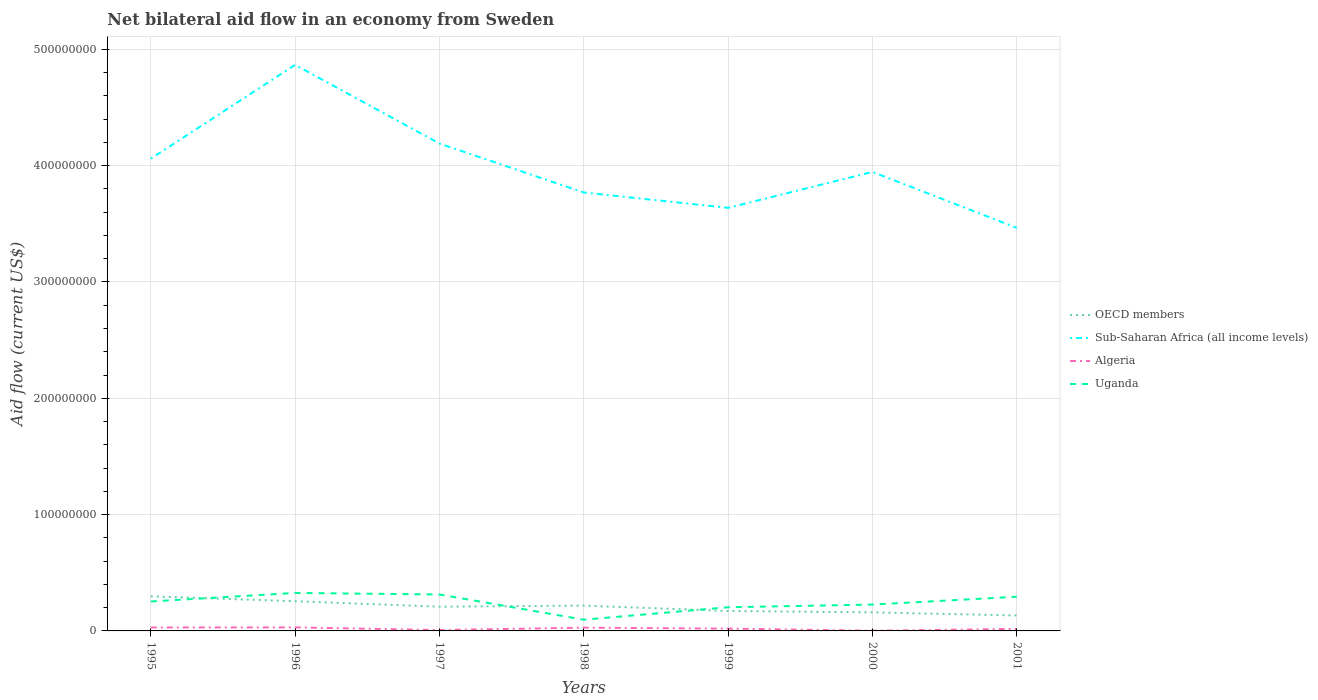Does the line corresponding to Sub-Saharan Africa (all income levels) intersect with the line corresponding to Uganda?
Provide a succinct answer. No. Is the number of lines equal to the number of legend labels?
Offer a terse response. Yes. Across all years, what is the maximum net bilateral aid flow in Sub-Saharan Africa (all income levels)?
Your response must be concise. 3.47e+08. In which year was the net bilateral aid flow in OECD members maximum?
Your answer should be compact. 2001. What is the total net bilateral aid flow in Algeria in the graph?
Your response must be concise. -9.60e+05. What is the difference between the highest and the second highest net bilateral aid flow in Uganda?
Offer a very short reply. 2.30e+07. Is the net bilateral aid flow in Sub-Saharan Africa (all income levels) strictly greater than the net bilateral aid flow in Algeria over the years?
Ensure brevity in your answer.  No. How many lines are there?
Give a very brief answer. 4. Does the graph contain any zero values?
Provide a short and direct response. No. Does the graph contain grids?
Give a very brief answer. Yes. Where does the legend appear in the graph?
Provide a succinct answer. Center right. How many legend labels are there?
Provide a succinct answer. 4. What is the title of the graph?
Provide a succinct answer. Net bilateral aid flow in an economy from Sweden. Does "Turkmenistan" appear as one of the legend labels in the graph?
Provide a succinct answer. No. What is the label or title of the X-axis?
Offer a terse response. Years. What is the Aid flow (current US$) of OECD members in 1995?
Keep it short and to the point. 2.97e+07. What is the Aid flow (current US$) in Sub-Saharan Africa (all income levels) in 1995?
Give a very brief answer. 4.06e+08. What is the Aid flow (current US$) in Algeria in 1995?
Keep it short and to the point. 2.96e+06. What is the Aid flow (current US$) in Uganda in 1995?
Keep it short and to the point. 2.53e+07. What is the Aid flow (current US$) in OECD members in 1996?
Your response must be concise. 2.55e+07. What is the Aid flow (current US$) of Sub-Saharan Africa (all income levels) in 1996?
Provide a succinct answer. 4.87e+08. What is the Aid flow (current US$) in Algeria in 1996?
Provide a succinct answer. 3.03e+06. What is the Aid flow (current US$) of Uganda in 1996?
Offer a terse response. 3.26e+07. What is the Aid flow (current US$) in OECD members in 1997?
Your answer should be very brief. 2.08e+07. What is the Aid flow (current US$) in Sub-Saharan Africa (all income levels) in 1997?
Your response must be concise. 4.19e+08. What is the Aid flow (current US$) of Algeria in 1997?
Offer a very short reply. 7.40e+05. What is the Aid flow (current US$) in Uganda in 1997?
Offer a very short reply. 3.13e+07. What is the Aid flow (current US$) in OECD members in 1998?
Provide a short and direct response. 2.18e+07. What is the Aid flow (current US$) in Sub-Saharan Africa (all income levels) in 1998?
Your answer should be very brief. 3.77e+08. What is the Aid flow (current US$) of Algeria in 1998?
Provide a short and direct response. 2.81e+06. What is the Aid flow (current US$) in Uganda in 1998?
Provide a short and direct response. 9.65e+06. What is the Aid flow (current US$) of OECD members in 1999?
Offer a very short reply. 1.72e+07. What is the Aid flow (current US$) of Sub-Saharan Africa (all income levels) in 1999?
Your answer should be very brief. 3.64e+08. What is the Aid flow (current US$) in Algeria in 1999?
Offer a very short reply. 1.95e+06. What is the Aid flow (current US$) in Uganda in 1999?
Make the answer very short. 2.03e+07. What is the Aid flow (current US$) in OECD members in 2000?
Provide a short and direct response. 1.60e+07. What is the Aid flow (current US$) in Sub-Saharan Africa (all income levels) in 2000?
Offer a terse response. 3.95e+08. What is the Aid flow (current US$) of Uganda in 2000?
Give a very brief answer. 2.26e+07. What is the Aid flow (current US$) in OECD members in 2001?
Your answer should be compact. 1.33e+07. What is the Aid flow (current US$) in Sub-Saharan Africa (all income levels) in 2001?
Your response must be concise. 3.47e+08. What is the Aid flow (current US$) in Algeria in 2001?
Make the answer very short. 1.70e+06. What is the Aid flow (current US$) of Uganda in 2001?
Offer a very short reply. 2.94e+07. Across all years, what is the maximum Aid flow (current US$) of OECD members?
Your response must be concise. 2.97e+07. Across all years, what is the maximum Aid flow (current US$) in Sub-Saharan Africa (all income levels)?
Your answer should be very brief. 4.87e+08. Across all years, what is the maximum Aid flow (current US$) of Algeria?
Give a very brief answer. 3.03e+06. Across all years, what is the maximum Aid flow (current US$) in Uganda?
Provide a short and direct response. 3.26e+07. Across all years, what is the minimum Aid flow (current US$) of OECD members?
Make the answer very short. 1.33e+07. Across all years, what is the minimum Aid flow (current US$) of Sub-Saharan Africa (all income levels)?
Make the answer very short. 3.47e+08. Across all years, what is the minimum Aid flow (current US$) of Uganda?
Your response must be concise. 9.65e+06. What is the total Aid flow (current US$) of OECD members in the graph?
Offer a terse response. 1.44e+08. What is the total Aid flow (current US$) of Sub-Saharan Africa (all income levels) in the graph?
Provide a short and direct response. 2.79e+09. What is the total Aid flow (current US$) in Algeria in the graph?
Offer a very short reply. 1.34e+07. What is the total Aid flow (current US$) in Uganda in the graph?
Make the answer very short. 1.71e+08. What is the difference between the Aid flow (current US$) of OECD members in 1995 and that in 1996?
Your answer should be very brief. 4.21e+06. What is the difference between the Aid flow (current US$) in Sub-Saharan Africa (all income levels) in 1995 and that in 1996?
Your answer should be very brief. -8.06e+07. What is the difference between the Aid flow (current US$) of Uganda in 1995 and that in 1996?
Offer a terse response. -7.34e+06. What is the difference between the Aid flow (current US$) in OECD members in 1995 and that in 1997?
Keep it short and to the point. 8.90e+06. What is the difference between the Aid flow (current US$) of Sub-Saharan Africa (all income levels) in 1995 and that in 1997?
Your answer should be very brief. -1.30e+07. What is the difference between the Aid flow (current US$) in Algeria in 1995 and that in 1997?
Ensure brevity in your answer.  2.22e+06. What is the difference between the Aid flow (current US$) of Uganda in 1995 and that in 1997?
Keep it short and to the point. -6.02e+06. What is the difference between the Aid flow (current US$) of OECD members in 1995 and that in 1998?
Keep it short and to the point. 7.98e+06. What is the difference between the Aid flow (current US$) of Sub-Saharan Africa (all income levels) in 1995 and that in 1998?
Your answer should be compact. 2.91e+07. What is the difference between the Aid flow (current US$) in Algeria in 1995 and that in 1998?
Keep it short and to the point. 1.50e+05. What is the difference between the Aid flow (current US$) of Uganda in 1995 and that in 1998?
Provide a short and direct response. 1.57e+07. What is the difference between the Aid flow (current US$) of OECD members in 1995 and that in 1999?
Offer a terse response. 1.26e+07. What is the difference between the Aid flow (current US$) in Sub-Saharan Africa (all income levels) in 1995 and that in 1999?
Make the answer very short. 4.23e+07. What is the difference between the Aid flow (current US$) of Algeria in 1995 and that in 1999?
Offer a very short reply. 1.01e+06. What is the difference between the Aid flow (current US$) of Uganda in 1995 and that in 1999?
Make the answer very short. 4.97e+06. What is the difference between the Aid flow (current US$) in OECD members in 1995 and that in 2000?
Your response must be concise. 1.38e+07. What is the difference between the Aid flow (current US$) in Sub-Saharan Africa (all income levels) in 1995 and that in 2000?
Give a very brief answer. 1.14e+07. What is the difference between the Aid flow (current US$) of Algeria in 1995 and that in 2000?
Keep it short and to the point. 2.76e+06. What is the difference between the Aid flow (current US$) in Uganda in 1995 and that in 2000?
Provide a succinct answer. 2.66e+06. What is the difference between the Aid flow (current US$) of OECD members in 1995 and that in 2001?
Keep it short and to the point. 1.64e+07. What is the difference between the Aid flow (current US$) in Sub-Saharan Africa (all income levels) in 1995 and that in 2001?
Provide a short and direct response. 5.94e+07. What is the difference between the Aid flow (current US$) in Algeria in 1995 and that in 2001?
Ensure brevity in your answer.  1.26e+06. What is the difference between the Aid flow (current US$) in Uganda in 1995 and that in 2001?
Your answer should be compact. -4.09e+06. What is the difference between the Aid flow (current US$) in OECD members in 1996 and that in 1997?
Ensure brevity in your answer.  4.69e+06. What is the difference between the Aid flow (current US$) of Sub-Saharan Africa (all income levels) in 1996 and that in 1997?
Ensure brevity in your answer.  6.76e+07. What is the difference between the Aid flow (current US$) of Algeria in 1996 and that in 1997?
Ensure brevity in your answer.  2.29e+06. What is the difference between the Aid flow (current US$) in Uganda in 1996 and that in 1997?
Ensure brevity in your answer.  1.32e+06. What is the difference between the Aid flow (current US$) in OECD members in 1996 and that in 1998?
Keep it short and to the point. 3.77e+06. What is the difference between the Aid flow (current US$) of Sub-Saharan Africa (all income levels) in 1996 and that in 1998?
Your response must be concise. 1.10e+08. What is the difference between the Aid flow (current US$) in Algeria in 1996 and that in 1998?
Your response must be concise. 2.20e+05. What is the difference between the Aid flow (current US$) in Uganda in 1996 and that in 1998?
Offer a very short reply. 2.30e+07. What is the difference between the Aid flow (current US$) in OECD members in 1996 and that in 1999?
Offer a terse response. 8.38e+06. What is the difference between the Aid flow (current US$) in Sub-Saharan Africa (all income levels) in 1996 and that in 1999?
Offer a terse response. 1.23e+08. What is the difference between the Aid flow (current US$) of Algeria in 1996 and that in 1999?
Keep it short and to the point. 1.08e+06. What is the difference between the Aid flow (current US$) of Uganda in 1996 and that in 1999?
Offer a terse response. 1.23e+07. What is the difference between the Aid flow (current US$) in OECD members in 1996 and that in 2000?
Your answer should be very brief. 9.57e+06. What is the difference between the Aid flow (current US$) in Sub-Saharan Africa (all income levels) in 1996 and that in 2000?
Offer a terse response. 9.20e+07. What is the difference between the Aid flow (current US$) in Algeria in 1996 and that in 2000?
Keep it short and to the point. 2.83e+06. What is the difference between the Aid flow (current US$) in OECD members in 1996 and that in 2001?
Your response must be concise. 1.22e+07. What is the difference between the Aid flow (current US$) of Sub-Saharan Africa (all income levels) in 1996 and that in 2001?
Your response must be concise. 1.40e+08. What is the difference between the Aid flow (current US$) of Algeria in 1996 and that in 2001?
Your answer should be compact. 1.33e+06. What is the difference between the Aid flow (current US$) in Uganda in 1996 and that in 2001?
Provide a short and direct response. 3.25e+06. What is the difference between the Aid flow (current US$) in OECD members in 1997 and that in 1998?
Ensure brevity in your answer.  -9.20e+05. What is the difference between the Aid flow (current US$) of Sub-Saharan Africa (all income levels) in 1997 and that in 1998?
Your answer should be compact. 4.21e+07. What is the difference between the Aid flow (current US$) of Algeria in 1997 and that in 1998?
Your response must be concise. -2.07e+06. What is the difference between the Aid flow (current US$) of Uganda in 1997 and that in 1998?
Your answer should be very brief. 2.17e+07. What is the difference between the Aid flow (current US$) of OECD members in 1997 and that in 1999?
Make the answer very short. 3.69e+06. What is the difference between the Aid flow (current US$) in Sub-Saharan Africa (all income levels) in 1997 and that in 1999?
Provide a succinct answer. 5.53e+07. What is the difference between the Aid flow (current US$) of Algeria in 1997 and that in 1999?
Give a very brief answer. -1.21e+06. What is the difference between the Aid flow (current US$) of Uganda in 1997 and that in 1999?
Make the answer very short. 1.10e+07. What is the difference between the Aid flow (current US$) in OECD members in 1997 and that in 2000?
Your answer should be compact. 4.88e+06. What is the difference between the Aid flow (current US$) in Sub-Saharan Africa (all income levels) in 1997 and that in 2000?
Your answer should be very brief. 2.44e+07. What is the difference between the Aid flow (current US$) in Algeria in 1997 and that in 2000?
Ensure brevity in your answer.  5.40e+05. What is the difference between the Aid flow (current US$) in Uganda in 1997 and that in 2000?
Give a very brief answer. 8.68e+06. What is the difference between the Aid flow (current US$) of OECD members in 1997 and that in 2001?
Your answer should be compact. 7.55e+06. What is the difference between the Aid flow (current US$) in Sub-Saharan Africa (all income levels) in 1997 and that in 2001?
Ensure brevity in your answer.  7.25e+07. What is the difference between the Aid flow (current US$) of Algeria in 1997 and that in 2001?
Provide a short and direct response. -9.60e+05. What is the difference between the Aid flow (current US$) of Uganda in 1997 and that in 2001?
Give a very brief answer. 1.93e+06. What is the difference between the Aid flow (current US$) of OECD members in 1998 and that in 1999?
Ensure brevity in your answer.  4.61e+06. What is the difference between the Aid flow (current US$) of Sub-Saharan Africa (all income levels) in 1998 and that in 1999?
Provide a succinct answer. 1.32e+07. What is the difference between the Aid flow (current US$) of Algeria in 1998 and that in 1999?
Offer a very short reply. 8.60e+05. What is the difference between the Aid flow (current US$) in Uganda in 1998 and that in 1999?
Keep it short and to the point. -1.07e+07. What is the difference between the Aid flow (current US$) of OECD members in 1998 and that in 2000?
Keep it short and to the point. 5.80e+06. What is the difference between the Aid flow (current US$) in Sub-Saharan Africa (all income levels) in 1998 and that in 2000?
Ensure brevity in your answer.  -1.77e+07. What is the difference between the Aid flow (current US$) in Algeria in 1998 and that in 2000?
Give a very brief answer. 2.61e+06. What is the difference between the Aid flow (current US$) of Uganda in 1998 and that in 2000?
Provide a succinct answer. -1.30e+07. What is the difference between the Aid flow (current US$) in OECD members in 1998 and that in 2001?
Your answer should be compact. 8.47e+06. What is the difference between the Aid flow (current US$) of Sub-Saharan Africa (all income levels) in 1998 and that in 2001?
Your answer should be compact. 3.04e+07. What is the difference between the Aid flow (current US$) in Algeria in 1998 and that in 2001?
Your answer should be compact. 1.11e+06. What is the difference between the Aid flow (current US$) of Uganda in 1998 and that in 2001?
Offer a very short reply. -1.98e+07. What is the difference between the Aid flow (current US$) in OECD members in 1999 and that in 2000?
Provide a succinct answer. 1.19e+06. What is the difference between the Aid flow (current US$) of Sub-Saharan Africa (all income levels) in 1999 and that in 2000?
Give a very brief answer. -3.09e+07. What is the difference between the Aid flow (current US$) of Algeria in 1999 and that in 2000?
Offer a very short reply. 1.75e+06. What is the difference between the Aid flow (current US$) in Uganda in 1999 and that in 2000?
Give a very brief answer. -2.31e+06. What is the difference between the Aid flow (current US$) of OECD members in 1999 and that in 2001?
Offer a terse response. 3.86e+06. What is the difference between the Aid flow (current US$) in Sub-Saharan Africa (all income levels) in 1999 and that in 2001?
Your answer should be compact. 1.72e+07. What is the difference between the Aid flow (current US$) in Algeria in 1999 and that in 2001?
Make the answer very short. 2.50e+05. What is the difference between the Aid flow (current US$) of Uganda in 1999 and that in 2001?
Keep it short and to the point. -9.06e+06. What is the difference between the Aid flow (current US$) of OECD members in 2000 and that in 2001?
Keep it short and to the point. 2.67e+06. What is the difference between the Aid flow (current US$) in Sub-Saharan Africa (all income levels) in 2000 and that in 2001?
Your answer should be compact. 4.81e+07. What is the difference between the Aid flow (current US$) in Algeria in 2000 and that in 2001?
Give a very brief answer. -1.50e+06. What is the difference between the Aid flow (current US$) of Uganda in 2000 and that in 2001?
Offer a very short reply. -6.75e+06. What is the difference between the Aid flow (current US$) in OECD members in 1995 and the Aid flow (current US$) in Sub-Saharan Africa (all income levels) in 1996?
Provide a succinct answer. -4.57e+08. What is the difference between the Aid flow (current US$) of OECD members in 1995 and the Aid flow (current US$) of Algeria in 1996?
Offer a terse response. 2.67e+07. What is the difference between the Aid flow (current US$) in OECD members in 1995 and the Aid flow (current US$) in Uganda in 1996?
Provide a succinct answer. -2.91e+06. What is the difference between the Aid flow (current US$) in Sub-Saharan Africa (all income levels) in 1995 and the Aid flow (current US$) in Algeria in 1996?
Offer a very short reply. 4.03e+08. What is the difference between the Aid flow (current US$) in Sub-Saharan Africa (all income levels) in 1995 and the Aid flow (current US$) in Uganda in 1996?
Your response must be concise. 3.73e+08. What is the difference between the Aid flow (current US$) in Algeria in 1995 and the Aid flow (current US$) in Uganda in 1996?
Keep it short and to the point. -2.97e+07. What is the difference between the Aid flow (current US$) of OECD members in 1995 and the Aid flow (current US$) of Sub-Saharan Africa (all income levels) in 1997?
Provide a succinct answer. -3.89e+08. What is the difference between the Aid flow (current US$) of OECD members in 1995 and the Aid flow (current US$) of Algeria in 1997?
Give a very brief answer. 2.90e+07. What is the difference between the Aid flow (current US$) in OECD members in 1995 and the Aid flow (current US$) in Uganda in 1997?
Offer a very short reply. -1.59e+06. What is the difference between the Aid flow (current US$) in Sub-Saharan Africa (all income levels) in 1995 and the Aid flow (current US$) in Algeria in 1997?
Ensure brevity in your answer.  4.05e+08. What is the difference between the Aid flow (current US$) in Sub-Saharan Africa (all income levels) in 1995 and the Aid flow (current US$) in Uganda in 1997?
Keep it short and to the point. 3.75e+08. What is the difference between the Aid flow (current US$) of Algeria in 1995 and the Aid flow (current US$) of Uganda in 1997?
Make the answer very short. -2.84e+07. What is the difference between the Aid flow (current US$) in OECD members in 1995 and the Aid flow (current US$) in Sub-Saharan Africa (all income levels) in 1998?
Offer a very short reply. -3.47e+08. What is the difference between the Aid flow (current US$) of OECD members in 1995 and the Aid flow (current US$) of Algeria in 1998?
Your answer should be very brief. 2.69e+07. What is the difference between the Aid flow (current US$) in OECD members in 1995 and the Aid flow (current US$) in Uganda in 1998?
Provide a short and direct response. 2.01e+07. What is the difference between the Aid flow (current US$) in Sub-Saharan Africa (all income levels) in 1995 and the Aid flow (current US$) in Algeria in 1998?
Provide a succinct answer. 4.03e+08. What is the difference between the Aid flow (current US$) in Sub-Saharan Africa (all income levels) in 1995 and the Aid flow (current US$) in Uganda in 1998?
Keep it short and to the point. 3.96e+08. What is the difference between the Aid flow (current US$) of Algeria in 1995 and the Aid flow (current US$) of Uganda in 1998?
Your response must be concise. -6.69e+06. What is the difference between the Aid flow (current US$) in OECD members in 1995 and the Aid flow (current US$) in Sub-Saharan Africa (all income levels) in 1999?
Your answer should be compact. -3.34e+08. What is the difference between the Aid flow (current US$) of OECD members in 1995 and the Aid flow (current US$) of Algeria in 1999?
Give a very brief answer. 2.78e+07. What is the difference between the Aid flow (current US$) of OECD members in 1995 and the Aid flow (current US$) of Uganda in 1999?
Your answer should be very brief. 9.40e+06. What is the difference between the Aid flow (current US$) of Sub-Saharan Africa (all income levels) in 1995 and the Aid flow (current US$) of Algeria in 1999?
Give a very brief answer. 4.04e+08. What is the difference between the Aid flow (current US$) in Sub-Saharan Africa (all income levels) in 1995 and the Aid flow (current US$) in Uganda in 1999?
Offer a very short reply. 3.86e+08. What is the difference between the Aid flow (current US$) in Algeria in 1995 and the Aid flow (current US$) in Uganda in 1999?
Your response must be concise. -1.74e+07. What is the difference between the Aid flow (current US$) of OECD members in 1995 and the Aid flow (current US$) of Sub-Saharan Africa (all income levels) in 2000?
Your answer should be compact. -3.65e+08. What is the difference between the Aid flow (current US$) in OECD members in 1995 and the Aid flow (current US$) in Algeria in 2000?
Your answer should be very brief. 2.95e+07. What is the difference between the Aid flow (current US$) in OECD members in 1995 and the Aid flow (current US$) in Uganda in 2000?
Ensure brevity in your answer.  7.09e+06. What is the difference between the Aid flow (current US$) of Sub-Saharan Africa (all income levels) in 1995 and the Aid flow (current US$) of Algeria in 2000?
Your response must be concise. 4.06e+08. What is the difference between the Aid flow (current US$) of Sub-Saharan Africa (all income levels) in 1995 and the Aid flow (current US$) of Uganda in 2000?
Keep it short and to the point. 3.83e+08. What is the difference between the Aid flow (current US$) in Algeria in 1995 and the Aid flow (current US$) in Uganda in 2000?
Keep it short and to the point. -1.97e+07. What is the difference between the Aid flow (current US$) in OECD members in 1995 and the Aid flow (current US$) in Sub-Saharan Africa (all income levels) in 2001?
Offer a very short reply. -3.17e+08. What is the difference between the Aid flow (current US$) of OECD members in 1995 and the Aid flow (current US$) of Algeria in 2001?
Provide a short and direct response. 2.80e+07. What is the difference between the Aid flow (current US$) of Sub-Saharan Africa (all income levels) in 1995 and the Aid flow (current US$) of Algeria in 2001?
Provide a succinct answer. 4.04e+08. What is the difference between the Aid flow (current US$) of Sub-Saharan Africa (all income levels) in 1995 and the Aid flow (current US$) of Uganda in 2001?
Offer a terse response. 3.77e+08. What is the difference between the Aid flow (current US$) in Algeria in 1995 and the Aid flow (current US$) in Uganda in 2001?
Offer a terse response. -2.64e+07. What is the difference between the Aid flow (current US$) in OECD members in 1996 and the Aid flow (current US$) in Sub-Saharan Africa (all income levels) in 1997?
Your answer should be very brief. -3.93e+08. What is the difference between the Aid flow (current US$) of OECD members in 1996 and the Aid flow (current US$) of Algeria in 1997?
Provide a short and direct response. 2.48e+07. What is the difference between the Aid flow (current US$) of OECD members in 1996 and the Aid flow (current US$) of Uganda in 1997?
Give a very brief answer. -5.80e+06. What is the difference between the Aid flow (current US$) of Sub-Saharan Africa (all income levels) in 1996 and the Aid flow (current US$) of Algeria in 1997?
Keep it short and to the point. 4.86e+08. What is the difference between the Aid flow (current US$) of Sub-Saharan Africa (all income levels) in 1996 and the Aid flow (current US$) of Uganda in 1997?
Ensure brevity in your answer.  4.55e+08. What is the difference between the Aid flow (current US$) in Algeria in 1996 and the Aid flow (current US$) in Uganda in 1997?
Your answer should be compact. -2.83e+07. What is the difference between the Aid flow (current US$) of OECD members in 1996 and the Aid flow (current US$) of Sub-Saharan Africa (all income levels) in 1998?
Your response must be concise. -3.51e+08. What is the difference between the Aid flow (current US$) of OECD members in 1996 and the Aid flow (current US$) of Algeria in 1998?
Your response must be concise. 2.27e+07. What is the difference between the Aid flow (current US$) of OECD members in 1996 and the Aid flow (current US$) of Uganda in 1998?
Your answer should be very brief. 1.59e+07. What is the difference between the Aid flow (current US$) of Sub-Saharan Africa (all income levels) in 1996 and the Aid flow (current US$) of Algeria in 1998?
Ensure brevity in your answer.  4.84e+08. What is the difference between the Aid flow (current US$) of Sub-Saharan Africa (all income levels) in 1996 and the Aid flow (current US$) of Uganda in 1998?
Offer a very short reply. 4.77e+08. What is the difference between the Aid flow (current US$) of Algeria in 1996 and the Aid flow (current US$) of Uganda in 1998?
Ensure brevity in your answer.  -6.62e+06. What is the difference between the Aid flow (current US$) of OECD members in 1996 and the Aid flow (current US$) of Sub-Saharan Africa (all income levels) in 1999?
Offer a very short reply. -3.38e+08. What is the difference between the Aid flow (current US$) of OECD members in 1996 and the Aid flow (current US$) of Algeria in 1999?
Ensure brevity in your answer.  2.36e+07. What is the difference between the Aid flow (current US$) in OECD members in 1996 and the Aid flow (current US$) in Uganda in 1999?
Offer a terse response. 5.19e+06. What is the difference between the Aid flow (current US$) of Sub-Saharan Africa (all income levels) in 1996 and the Aid flow (current US$) of Algeria in 1999?
Ensure brevity in your answer.  4.85e+08. What is the difference between the Aid flow (current US$) in Sub-Saharan Africa (all income levels) in 1996 and the Aid flow (current US$) in Uganda in 1999?
Provide a short and direct response. 4.66e+08. What is the difference between the Aid flow (current US$) of Algeria in 1996 and the Aid flow (current US$) of Uganda in 1999?
Offer a terse response. -1.73e+07. What is the difference between the Aid flow (current US$) of OECD members in 1996 and the Aid flow (current US$) of Sub-Saharan Africa (all income levels) in 2000?
Offer a very short reply. -3.69e+08. What is the difference between the Aid flow (current US$) of OECD members in 1996 and the Aid flow (current US$) of Algeria in 2000?
Provide a short and direct response. 2.53e+07. What is the difference between the Aid flow (current US$) of OECD members in 1996 and the Aid flow (current US$) of Uganda in 2000?
Your response must be concise. 2.88e+06. What is the difference between the Aid flow (current US$) in Sub-Saharan Africa (all income levels) in 1996 and the Aid flow (current US$) in Algeria in 2000?
Offer a very short reply. 4.86e+08. What is the difference between the Aid flow (current US$) in Sub-Saharan Africa (all income levels) in 1996 and the Aid flow (current US$) in Uganda in 2000?
Your response must be concise. 4.64e+08. What is the difference between the Aid flow (current US$) of Algeria in 1996 and the Aid flow (current US$) of Uganda in 2000?
Make the answer very short. -1.96e+07. What is the difference between the Aid flow (current US$) of OECD members in 1996 and the Aid flow (current US$) of Sub-Saharan Africa (all income levels) in 2001?
Provide a short and direct response. -3.21e+08. What is the difference between the Aid flow (current US$) in OECD members in 1996 and the Aid flow (current US$) in Algeria in 2001?
Your response must be concise. 2.38e+07. What is the difference between the Aid flow (current US$) in OECD members in 1996 and the Aid flow (current US$) in Uganda in 2001?
Your answer should be compact. -3.87e+06. What is the difference between the Aid flow (current US$) in Sub-Saharan Africa (all income levels) in 1996 and the Aid flow (current US$) in Algeria in 2001?
Give a very brief answer. 4.85e+08. What is the difference between the Aid flow (current US$) in Sub-Saharan Africa (all income levels) in 1996 and the Aid flow (current US$) in Uganda in 2001?
Provide a succinct answer. 4.57e+08. What is the difference between the Aid flow (current US$) in Algeria in 1996 and the Aid flow (current US$) in Uganda in 2001?
Give a very brief answer. -2.64e+07. What is the difference between the Aid flow (current US$) of OECD members in 1997 and the Aid flow (current US$) of Sub-Saharan Africa (all income levels) in 1998?
Offer a terse response. -3.56e+08. What is the difference between the Aid flow (current US$) of OECD members in 1997 and the Aid flow (current US$) of Algeria in 1998?
Your answer should be compact. 1.80e+07. What is the difference between the Aid flow (current US$) in OECD members in 1997 and the Aid flow (current US$) in Uganda in 1998?
Your response must be concise. 1.12e+07. What is the difference between the Aid flow (current US$) of Sub-Saharan Africa (all income levels) in 1997 and the Aid flow (current US$) of Algeria in 1998?
Keep it short and to the point. 4.16e+08. What is the difference between the Aid flow (current US$) of Sub-Saharan Africa (all income levels) in 1997 and the Aid flow (current US$) of Uganda in 1998?
Give a very brief answer. 4.09e+08. What is the difference between the Aid flow (current US$) in Algeria in 1997 and the Aid flow (current US$) in Uganda in 1998?
Your answer should be very brief. -8.91e+06. What is the difference between the Aid flow (current US$) in OECD members in 1997 and the Aid flow (current US$) in Sub-Saharan Africa (all income levels) in 1999?
Your answer should be compact. -3.43e+08. What is the difference between the Aid flow (current US$) in OECD members in 1997 and the Aid flow (current US$) in Algeria in 1999?
Your answer should be very brief. 1.89e+07. What is the difference between the Aid flow (current US$) of OECD members in 1997 and the Aid flow (current US$) of Uganda in 1999?
Offer a very short reply. 5.00e+05. What is the difference between the Aid flow (current US$) in Sub-Saharan Africa (all income levels) in 1997 and the Aid flow (current US$) in Algeria in 1999?
Your response must be concise. 4.17e+08. What is the difference between the Aid flow (current US$) of Sub-Saharan Africa (all income levels) in 1997 and the Aid flow (current US$) of Uganda in 1999?
Your answer should be very brief. 3.99e+08. What is the difference between the Aid flow (current US$) of Algeria in 1997 and the Aid flow (current US$) of Uganda in 1999?
Ensure brevity in your answer.  -1.96e+07. What is the difference between the Aid flow (current US$) of OECD members in 1997 and the Aid flow (current US$) of Sub-Saharan Africa (all income levels) in 2000?
Keep it short and to the point. -3.74e+08. What is the difference between the Aid flow (current US$) of OECD members in 1997 and the Aid flow (current US$) of Algeria in 2000?
Your answer should be very brief. 2.06e+07. What is the difference between the Aid flow (current US$) in OECD members in 1997 and the Aid flow (current US$) in Uganda in 2000?
Your response must be concise. -1.81e+06. What is the difference between the Aid flow (current US$) of Sub-Saharan Africa (all income levels) in 1997 and the Aid flow (current US$) of Algeria in 2000?
Your answer should be very brief. 4.19e+08. What is the difference between the Aid flow (current US$) in Sub-Saharan Africa (all income levels) in 1997 and the Aid flow (current US$) in Uganda in 2000?
Make the answer very short. 3.96e+08. What is the difference between the Aid flow (current US$) in Algeria in 1997 and the Aid flow (current US$) in Uganda in 2000?
Keep it short and to the point. -2.19e+07. What is the difference between the Aid flow (current US$) in OECD members in 1997 and the Aid flow (current US$) in Sub-Saharan Africa (all income levels) in 2001?
Your answer should be compact. -3.26e+08. What is the difference between the Aid flow (current US$) in OECD members in 1997 and the Aid flow (current US$) in Algeria in 2001?
Provide a succinct answer. 1.91e+07. What is the difference between the Aid flow (current US$) of OECD members in 1997 and the Aid flow (current US$) of Uganda in 2001?
Provide a short and direct response. -8.56e+06. What is the difference between the Aid flow (current US$) of Sub-Saharan Africa (all income levels) in 1997 and the Aid flow (current US$) of Algeria in 2001?
Offer a very short reply. 4.17e+08. What is the difference between the Aid flow (current US$) of Sub-Saharan Africa (all income levels) in 1997 and the Aid flow (current US$) of Uganda in 2001?
Your answer should be very brief. 3.90e+08. What is the difference between the Aid flow (current US$) of Algeria in 1997 and the Aid flow (current US$) of Uganda in 2001?
Offer a terse response. -2.87e+07. What is the difference between the Aid flow (current US$) in OECD members in 1998 and the Aid flow (current US$) in Sub-Saharan Africa (all income levels) in 1999?
Offer a terse response. -3.42e+08. What is the difference between the Aid flow (current US$) of OECD members in 1998 and the Aid flow (current US$) of Algeria in 1999?
Keep it short and to the point. 1.98e+07. What is the difference between the Aid flow (current US$) in OECD members in 1998 and the Aid flow (current US$) in Uganda in 1999?
Your response must be concise. 1.42e+06. What is the difference between the Aid flow (current US$) in Sub-Saharan Africa (all income levels) in 1998 and the Aid flow (current US$) in Algeria in 1999?
Provide a succinct answer. 3.75e+08. What is the difference between the Aid flow (current US$) in Sub-Saharan Africa (all income levels) in 1998 and the Aid flow (current US$) in Uganda in 1999?
Make the answer very short. 3.57e+08. What is the difference between the Aid flow (current US$) of Algeria in 1998 and the Aid flow (current US$) of Uganda in 1999?
Make the answer very short. -1.75e+07. What is the difference between the Aid flow (current US$) in OECD members in 1998 and the Aid flow (current US$) in Sub-Saharan Africa (all income levels) in 2000?
Provide a short and direct response. -3.73e+08. What is the difference between the Aid flow (current US$) of OECD members in 1998 and the Aid flow (current US$) of Algeria in 2000?
Offer a terse response. 2.16e+07. What is the difference between the Aid flow (current US$) in OECD members in 1998 and the Aid flow (current US$) in Uganda in 2000?
Give a very brief answer. -8.90e+05. What is the difference between the Aid flow (current US$) of Sub-Saharan Africa (all income levels) in 1998 and the Aid flow (current US$) of Algeria in 2000?
Ensure brevity in your answer.  3.77e+08. What is the difference between the Aid flow (current US$) of Sub-Saharan Africa (all income levels) in 1998 and the Aid flow (current US$) of Uganda in 2000?
Give a very brief answer. 3.54e+08. What is the difference between the Aid flow (current US$) of Algeria in 1998 and the Aid flow (current US$) of Uganda in 2000?
Your answer should be compact. -1.98e+07. What is the difference between the Aid flow (current US$) in OECD members in 1998 and the Aid flow (current US$) in Sub-Saharan Africa (all income levels) in 2001?
Ensure brevity in your answer.  -3.25e+08. What is the difference between the Aid flow (current US$) in OECD members in 1998 and the Aid flow (current US$) in Algeria in 2001?
Provide a succinct answer. 2.01e+07. What is the difference between the Aid flow (current US$) of OECD members in 1998 and the Aid flow (current US$) of Uganda in 2001?
Ensure brevity in your answer.  -7.64e+06. What is the difference between the Aid flow (current US$) in Sub-Saharan Africa (all income levels) in 1998 and the Aid flow (current US$) in Algeria in 2001?
Give a very brief answer. 3.75e+08. What is the difference between the Aid flow (current US$) in Sub-Saharan Africa (all income levels) in 1998 and the Aid flow (current US$) in Uganda in 2001?
Keep it short and to the point. 3.48e+08. What is the difference between the Aid flow (current US$) of Algeria in 1998 and the Aid flow (current US$) of Uganda in 2001?
Make the answer very short. -2.66e+07. What is the difference between the Aid flow (current US$) in OECD members in 1999 and the Aid flow (current US$) in Sub-Saharan Africa (all income levels) in 2000?
Provide a short and direct response. -3.77e+08. What is the difference between the Aid flow (current US$) in OECD members in 1999 and the Aid flow (current US$) in Algeria in 2000?
Give a very brief answer. 1.70e+07. What is the difference between the Aid flow (current US$) in OECD members in 1999 and the Aid flow (current US$) in Uganda in 2000?
Your response must be concise. -5.50e+06. What is the difference between the Aid flow (current US$) of Sub-Saharan Africa (all income levels) in 1999 and the Aid flow (current US$) of Algeria in 2000?
Keep it short and to the point. 3.64e+08. What is the difference between the Aid flow (current US$) of Sub-Saharan Africa (all income levels) in 1999 and the Aid flow (current US$) of Uganda in 2000?
Make the answer very short. 3.41e+08. What is the difference between the Aid flow (current US$) of Algeria in 1999 and the Aid flow (current US$) of Uganda in 2000?
Your response must be concise. -2.07e+07. What is the difference between the Aid flow (current US$) of OECD members in 1999 and the Aid flow (current US$) of Sub-Saharan Africa (all income levels) in 2001?
Your response must be concise. -3.29e+08. What is the difference between the Aid flow (current US$) in OECD members in 1999 and the Aid flow (current US$) in Algeria in 2001?
Ensure brevity in your answer.  1.54e+07. What is the difference between the Aid flow (current US$) of OECD members in 1999 and the Aid flow (current US$) of Uganda in 2001?
Ensure brevity in your answer.  -1.22e+07. What is the difference between the Aid flow (current US$) in Sub-Saharan Africa (all income levels) in 1999 and the Aid flow (current US$) in Algeria in 2001?
Keep it short and to the point. 3.62e+08. What is the difference between the Aid flow (current US$) in Sub-Saharan Africa (all income levels) in 1999 and the Aid flow (current US$) in Uganda in 2001?
Offer a very short reply. 3.34e+08. What is the difference between the Aid flow (current US$) in Algeria in 1999 and the Aid flow (current US$) in Uganda in 2001?
Provide a succinct answer. -2.74e+07. What is the difference between the Aid flow (current US$) of OECD members in 2000 and the Aid flow (current US$) of Sub-Saharan Africa (all income levels) in 2001?
Ensure brevity in your answer.  -3.31e+08. What is the difference between the Aid flow (current US$) of OECD members in 2000 and the Aid flow (current US$) of Algeria in 2001?
Offer a very short reply. 1.43e+07. What is the difference between the Aid flow (current US$) of OECD members in 2000 and the Aid flow (current US$) of Uganda in 2001?
Give a very brief answer. -1.34e+07. What is the difference between the Aid flow (current US$) of Sub-Saharan Africa (all income levels) in 2000 and the Aid flow (current US$) of Algeria in 2001?
Offer a terse response. 3.93e+08. What is the difference between the Aid flow (current US$) in Sub-Saharan Africa (all income levels) in 2000 and the Aid flow (current US$) in Uganda in 2001?
Offer a terse response. 3.65e+08. What is the difference between the Aid flow (current US$) of Algeria in 2000 and the Aid flow (current US$) of Uganda in 2001?
Give a very brief answer. -2.92e+07. What is the average Aid flow (current US$) in OECD members per year?
Keep it short and to the point. 2.06e+07. What is the average Aid flow (current US$) in Sub-Saharan Africa (all income levels) per year?
Keep it short and to the point. 3.99e+08. What is the average Aid flow (current US$) in Algeria per year?
Keep it short and to the point. 1.91e+06. What is the average Aid flow (current US$) in Uganda per year?
Keep it short and to the point. 2.45e+07. In the year 1995, what is the difference between the Aid flow (current US$) in OECD members and Aid flow (current US$) in Sub-Saharan Africa (all income levels)?
Offer a terse response. -3.76e+08. In the year 1995, what is the difference between the Aid flow (current US$) in OECD members and Aid flow (current US$) in Algeria?
Provide a succinct answer. 2.68e+07. In the year 1995, what is the difference between the Aid flow (current US$) of OECD members and Aid flow (current US$) of Uganda?
Your response must be concise. 4.43e+06. In the year 1995, what is the difference between the Aid flow (current US$) of Sub-Saharan Africa (all income levels) and Aid flow (current US$) of Algeria?
Ensure brevity in your answer.  4.03e+08. In the year 1995, what is the difference between the Aid flow (current US$) of Sub-Saharan Africa (all income levels) and Aid flow (current US$) of Uganda?
Your answer should be very brief. 3.81e+08. In the year 1995, what is the difference between the Aid flow (current US$) of Algeria and Aid flow (current US$) of Uganda?
Your response must be concise. -2.24e+07. In the year 1996, what is the difference between the Aid flow (current US$) in OECD members and Aid flow (current US$) in Sub-Saharan Africa (all income levels)?
Keep it short and to the point. -4.61e+08. In the year 1996, what is the difference between the Aid flow (current US$) in OECD members and Aid flow (current US$) in Algeria?
Provide a short and direct response. 2.25e+07. In the year 1996, what is the difference between the Aid flow (current US$) in OECD members and Aid flow (current US$) in Uganda?
Your response must be concise. -7.12e+06. In the year 1996, what is the difference between the Aid flow (current US$) of Sub-Saharan Africa (all income levels) and Aid flow (current US$) of Algeria?
Your answer should be compact. 4.84e+08. In the year 1996, what is the difference between the Aid flow (current US$) in Sub-Saharan Africa (all income levels) and Aid flow (current US$) in Uganda?
Your answer should be very brief. 4.54e+08. In the year 1996, what is the difference between the Aid flow (current US$) in Algeria and Aid flow (current US$) in Uganda?
Offer a terse response. -2.96e+07. In the year 1997, what is the difference between the Aid flow (current US$) of OECD members and Aid flow (current US$) of Sub-Saharan Africa (all income levels)?
Provide a succinct answer. -3.98e+08. In the year 1997, what is the difference between the Aid flow (current US$) in OECD members and Aid flow (current US$) in Algeria?
Your answer should be very brief. 2.01e+07. In the year 1997, what is the difference between the Aid flow (current US$) of OECD members and Aid flow (current US$) of Uganda?
Your answer should be compact. -1.05e+07. In the year 1997, what is the difference between the Aid flow (current US$) in Sub-Saharan Africa (all income levels) and Aid flow (current US$) in Algeria?
Ensure brevity in your answer.  4.18e+08. In the year 1997, what is the difference between the Aid flow (current US$) in Sub-Saharan Africa (all income levels) and Aid flow (current US$) in Uganda?
Ensure brevity in your answer.  3.88e+08. In the year 1997, what is the difference between the Aid flow (current US$) in Algeria and Aid flow (current US$) in Uganda?
Your answer should be compact. -3.06e+07. In the year 1998, what is the difference between the Aid flow (current US$) of OECD members and Aid flow (current US$) of Sub-Saharan Africa (all income levels)?
Offer a terse response. -3.55e+08. In the year 1998, what is the difference between the Aid flow (current US$) of OECD members and Aid flow (current US$) of Algeria?
Keep it short and to the point. 1.90e+07. In the year 1998, what is the difference between the Aid flow (current US$) in OECD members and Aid flow (current US$) in Uganda?
Give a very brief answer. 1.21e+07. In the year 1998, what is the difference between the Aid flow (current US$) of Sub-Saharan Africa (all income levels) and Aid flow (current US$) of Algeria?
Give a very brief answer. 3.74e+08. In the year 1998, what is the difference between the Aid flow (current US$) of Sub-Saharan Africa (all income levels) and Aid flow (current US$) of Uganda?
Keep it short and to the point. 3.67e+08. In the year 1998, what is the difference between the Aid flow (current US$) of Algeria and Aid flow (current US$) of Uganda?
Give a very brief answer. -6.84e+06. In the year 1999, what is the difference between the Aid flow (current US$) in OECD members and Aid flow (current US$) in Sub-Saharan Africa (all income levels)?
Make the answer very short. -3.47e+08. In the year 1999, what is the difference between the Aid flow (current US$) of OECD members and Aid flow (current US$) of Algeria?
Give a very brief answer. 1.52e+07. In the year 1999, what is the difference between the Aid flow (current US$) in OECD members and Aid flow (current US$) in Uganda?
Give a very brief answer. -3.19e+06. In the year 1999, what is the difference between the Aid flow (current US$) in Sub-Saharan Africa (all income levels) and Aid flow (current US$) in Algeria?
Your answer should be very brief. 3.62e+08. In the year 1999, what is the difference between the Aid flow (current US$) in Sub-Saharan Africa (all income levels) and Aid flow (current US$) in Uganda?
Your response must be concise. 3.43e+08. In the year 1999, what is the difference between the Aid flow (current US$) of Algeria and Aid flow (current US$) of Uganda?
Make the answer very short. -1.84e+07. In the year 2000, what is the difference between the Aid flow (current US$) in OECD members and Aid flow (current US$) in Sub-Saharan Africa (all income levels)?
Provide a short and direct response. -3.79e+08. In the year 2000, what is the difference between the Aid flow (current US$) in OECD members and Aid flow (current US$) in Algeria?
Give a very brief answer. 1.58e+07. In the year 2000, what is the difference between the Aid flow (current US$) in OECD members and Aid flow (current US$) in Uganda?
Your response must be concise. -6.69e+06. In the year 2000, what is the difference between the Aid flow (current US$) of Sub-Saharan Africa (all income levels) and Aid flow (current US$) of Algeria?
Provide a short and direct response. 3.94e+08. In the year 2000, what is the difference between the Aid flow (current US$) of Sub-Saharan Africa (all income levels) and Aid flow (current US$) of Uganda?
Your response must be concise. 3.72e+08. In the year 2000, what is the difference between the Aid flow (current US$) of Algeria and Aid flow (current US$) of Uganda?
Make the answer very short. -2.24e+07. In the year 2001, what is the difference between the Aid flow (current US$) of OECD members and Aid flow (current US$) of Sub-Saharan Africa (all income levels)?
Offer a very short reply. -3.33e+08. In the year 2001, what is the difference between the Aid flow (current US$) in OECD members and Aid flow (current US$) in Algeria?
Your answer should be very brief. 1.16e+07. In the year 2001, what is the difference between the Aid flow (current US$) of OECD members and Aid flow (current US$) of Uganda?
Offer a very short reply. -1.61e+07. In the year 2001, what is the difference between the Aid flow (current US$) of Sub-Saharan Africa (all income levels) and Aid flow (current US$) of Algeria?
Offer a very short reply. 3.45e+08. In the year 2001, what is the difference between the Aid flow (current US$) in Sub-Saharan Africa (all income levels) and Aid flow (current US$) in Uganda?
Give a very brief answer. 3.17e+08. In the year 2001, what is the difference between the Aid flow (current US$) of Algeria and Aid flow (current US$) of Uganda?
Offer a terse response. -2.77e+07. What is the ratio of the Aid flow (current US$) in OECD members in 1995 to that in 1996?
Provide a succinct answer. 1.16. What is the ratio of the Aid flow (current US$) of Sub-Saharan Africa (all income levels) in 1995 to that in 1996?
Make the answer very short. 0.83. What is the ratio of the Aid flow (current US$) of Algeria in 1995 to that in 1996?
Provide a succinct answer. 0.98. What is the ratio of the Aid flow (current US$) in Uganda in 1995 to that in 1996?
Make the answer very short. 0.78. What is the ratio of the Aid flow (current US$) in OECD members in 1995 to that in 1997?
Offer a very short reply. 1.43. What is the ratio of the Aid flow (current US$) in Sub-Saharan Africa (all income levels) in 1995 to that in 1997?
Your answer should be very brief. 0.97. What is the ratio of the Aid flow (current US$) of Uganda in 1995 to that in 1997?
Provide a short and direct response. 0.81. What is the ratio of the Aid flow (current US$) of OECD members in 1995 to that in 1998?
Make the answer very short. 1.37. What is the ratio of the Aid flow (current US$) of Sub-Saharan Africa (all income levels) in 1995 to that in 1998?
Your answer should be very brief. 1.08. What is the ratio of the Aid flow (current US$) of Algeria in 1995 to that in 1998?
Your response must be concise. 1.05. What is the ratio of the Aid flow (current US$) of Uganda in 1995 to that in 1998?
Your response must be concise. 2.62. What is the ratio of the Aid flow (current US$) in OECD members in 1995 to that in 1999?
Your answer should be compact. 1.73. What is the ratio of the Aid flow (current US$) in Sub-Saharan Africa (all income levels) in 1995 to that in 1999?
Your response must be concise. 1.12. What is the ratio of the Aid flow (current US$) of Algeria in 1995 to that in 1999?
Offer a very short reply. 1.52. What is the ratio of the Aid flow (current US$) of Uganda in 1995 to that in 1999?
Offer a very short reply. 1.24. What is the ratio of the Aid flow (current US$) in OECD members in 1995 to that in 2000?
Make the answer very short. 1.86. What is the ratio of the Aid flow (current US$) of Sub-Saharan Africa (all income levels) in 1995 to that in 2000?
Offer a terse response. 1.03. What is the ratio of the Aid flow (current US$) in Uganda in 1995 to that in 2000?
Offer a terse response. 1.12. What is the ratio of the Aid flow (current US$) of OECD members in 1995 to that in 2001?
Give a very brief answer. 2.24. What is the ratio of the Aid flow (current US$) in Sub-Saharan Africa (all income levels) in 1995 to that in 2001?
Give a very brief answer. 1.17. What is the ratio of the Aid flow (current US$) of Algeria in 1995 to that in 2001?
Offer a very short reply. 1.74. What is the ratio of the Aid flow (current US$) in Uganda in 1995 to that in 2001?
Your answer should be compact. 0.86. What is the ratio of the Aid flow (current US$) in OECD members in 1996 to that in 1997?
Provide a succinct answer. 1.23. What is the ratio of the Aid flow (current US$) of Sub-Saharan Africa (all income levels) in 1996 to that in 1997?
Offer a very short reply. 1.16. What is the ratio of the Aid flow (current US$) of Algeria in 1996 to that in 1997?
Make the answer very short. 4.09. What is the ratio of the Aid flow (current US$) in Uganda in 1996 to that in 1997?
Provide a succinct answer. 1.04. What is the ratio of the Aid flow (current US$) in OECD members in 1996 to that in 1998?
Your answer should be very brief. 1.17. What is the ratio of the Aid flow (current US$) in Sub-Saharan Africa (all income levels) in 1996 to that in 1998?
Offer a terse response. 1.29. What is the ratio of the Aid flow (current US$) of Algeria in 1996 to that in 1998?
Give a very brief answer. 1.08. What is the ratio of the Aid flow (current US$) in Uganda in 1996 to that in 1998?
Offer a terse response. 3.38. What is the ratio of the Aid flow (current US$) of OECD members in 1996 to that in 1999?
Provide a short and direct response. 1.49. What is the ratio of the Aid flow (current US$) in Sub-Saharan Africa (all income levels) in 1996 to that in 1999?
Offer a terse response. 1.34. What is the ratio of the Aid flow (current US$) of Algeria in 1996 to that in 1999?
Your response must be concise. 1.55. What is the ratio of the Aid flow (current US$) of Uganda in 1996 to that in 1999?
Give a very brief answer. 1.61. What is the ratio of the Aid flow (current US$) in OECD members in 1996 to that in 2000?
Keep it short and to the point. 1.6. What is the ratio of the Aid flow (current US$) in Sub-Saharan Africa (all income levels) in 1996 to that in 2000?
Provide a succinct answer. 1.23. What is the ratio of the Aid flow (current US$) in Algeria in 1996 to that in 2000?
Provide a succinct answer. 15.15. What is the ratio of the Aid flow (current US$) of Uganda in 1996 to that in 2000?
Your response must be concise. 1.44. What is the ratio of the Aid flow (current US$) of OECD members in 1996 to that in 2001?
Offer a very short reply. 1.92. What is the ratio of the Aid flow (current US$) in Sub-Saharan Africa (all income levels) in 1996 to that in 2001?
Give a very brief answer. 1.4. What is the ratio of the Aid flow (current US$) in Algeria in 1996 to that in 2001?
Keep it short and to the point. 1.78. What is the ratio of the Aid flow (current US$) of Uganda in 1996 to that in 2001?
Ensure brevity in your answer.  1.11. What is the ratio of the Aid flow (current US$) of OECD members in 1997 to that in 1998?
Your answer should be very brief. 0.96. What is the ratio of the Aid flow (current US$) in Sub-Saharan Africa (all income levels) in 1997 to that in 1998?
Offer a very short reply. 1.11. What is the ratio of the Aid flow (current US$) in Algeria in 1997 to that in 1998?
Provide a succinct answer. 0.26. What is the ratio of the Aid flow (current US$) of Uganda in 1997 to that in 1998?
Keep it short and to the point. 3.25. What is the ratio of the Aid flow (current US$) of OECD members in 1997 to that in 1999?
Your answer should be compact. 1.22. What is the ratio of the Aid flow (current US$) in Sub-Saharan Africa (all income levels) in 1997 to that in 1999?
Provide a short and direct response. 1.15. What is the ratio of the Aid flow (current US$) in Algeria in 1997 to that in 1999?
Give a very brief answer. 0.38. What is the ratio of the Aid flow (current US$) of Uganda in 1997 to that in 1999?
Keep it short and to the point. 1.54. What is the ratio of the Aid flow (current US$) in OECD members in 1997 to that in 2000?
Ensure brevity in your answer.  1.31. What is the ratio of the Aid flow (current US$) of Sub-Saharan Africa (all income levels) in 1997 to that in 2000?
Provide a short and direct response. 1.06. What is the ratio of the Aid flow (current US$) in Algeria in 1997 to that in 2000?
Keep it short and to the point. 3.7. What is the ratio of the Aid flow (current US$) in Uganda in 1997 to that in 2000?
Provide a short and direct response. 1.38. What is the ratio of the Aid flow (current US$) in OECD members in 1997 to that in 2001?
Make the answer very short. 1.57. What is the ratio of the Aid flow (current US$) of Sub-Saharan Africa (all income levels) in 1997 to that in 2001?
Ensure brevity in your answer.  1.21. What is the ratio of the Aid flow (current US$) in Algeria in 1997 to that in 2001?
Offer a terse response. 0.44. What is the ratio of the Aid flow (current US$) of Uganda in 1997 to that in 2001?
Your answer should be compact. 1.07. What is the ratio of the Aid flow (current US$) in OECD members in 1998 to that in 1999?
Offer a very short reply. 1.27. What is the ratio of the Aid flow (current US$) in Sub-Saharan Africa (all income levels) in 1998 to that in 1999?
Your response must be concise. 1.04. What is the ratio of the Aid flow (current US$) in Algeria in 1998 to that in 1999?
Give a very brief answer. 1.44. What is the ratio of the Aid flow (current US$) in Uganda in 1998 to that in 1999?
Provide a succinct answer. 0.47. What is the ratio of the Aid flow (current US$) of OECD members in 1998 to that in 2000?
Your answer should be compact. 1.36. What is the ratio of the Aid flow (current US$) of Sub-Saharan Africa (all income levels) in 1998 to that in 2000?
Provide a short and direct response. 0.96. What is the ratio of the Aid flow (current US$) of Algeria in 1998 to that in 2000?
Your response must be concise. 14.05. What is the ratio of the Aid flow (current US$) in Uganda in 1998 to that in 2000?
Ensure brevity in your answer.  0.43. What is the ratio of the Aid flow (current US$) in OECD members in 1998 to that in 2001?
Your answer should be compact. 1.64. What is the ratio of the Aid flow (current US$) in Sub-Saharan Africa (all income levels) in 1998 to that in 2001?
Your answer should be very brief. 1.09. What is the ratio of the Aid flow (current US$) in Algeria in 1998 to that in 2001?
Provide a short and direct response. 1.65. What is the ratio of the Aid flow (current US$) in Uganda in 1998 to that in 2001?
Offer a terse response. 0.33. What is the ratio of the Aid flow (current US$) of OECD members in 1999 to that in 2000?
Provide a short and direct response. 1.07. What is the ratio of the Aid flow (current US$) in Sub-Saharan Africa (all income levels) in 1999 to that in 2000?
Your response must be concise. 0.92. What is the ratio of the Aid flow (current US$) in Algeria in 1999 to that in 2000?
Ensure brevity in your answer.  9.75. What is the ratio of the Aid flow (current US$) in Uganda in 1999 to that in 2000?
Ensure brevity in your answer.  0.9. What is the ratio of the Aid flow (current US$) in OECD members in 1999 to that in 2001?
Ensure brevity in your answer.  1.29. What is the ratio of the Aid flow (current US$) in Sub-Saharan Africa (all income levels) in 1999 to that in 2001?
Ensure brevity in your answer.  1.05. What is the ratio of the Aid flow (current US$) in Algeria in 1999 to that in 2001?
Offer a terse response. 1.15. What is the ratio of the Aid flow (current US$) in Uganda in 1999 to that in 2001?
Provide a short and direct response. 0.69. What is the ratio of the Aid flow (current US$) of OECD members in 2000 to that in 2001?
Offer a terse response. 1.2. What is the ratio of the Aid flow (current US$) of Sub-Saharan Africa (all income levels) in 2000 to that in 2001?
Provide a succinct answer. 1.14. What is the ratio of the Aid flow (current US$) in Algeria in 2000 to that in 2001?
Ensure brevity in your answer.  0.12. What is the ratio of the Aid flow (current US$) of Uganda in 2000 to that in 2001?
Provide a succinct answer. 0.77. What is the difference between the highest and the second highest Aid flow (current US$) in OECD members?
Your answer should be very brief. 4.21e+06. What is the difference between the highest and the second highest Aid flow (current US$) in Sub-Saharan Africa (all income levels)?
Give a very brief answer. 6.76e+07. What is the difference between the highest and the second highest Aid flow (current US$) of Algeria?
Your response must be concise. 7.00e+04. What is the difference between the highest and the second highest Aid flow (current US$) of Uganda?
Keep it short and to the point. 1.32e+06. What is the difference between the highest and the lowest Aid flow (current US$) in OECD members?
Your response must be concise. 1.64e+07. What is the difference between the highest and the lowest Aid flow (current US$) of Sub-Saharan Africa (all income levels)?
Offer a terse response. 1.40e+08. What is the difference between the highest and the lowest Aid flow (current US$) of Algeria?
Your answer should be very brief. 2.83e+06. What is the difference between the highest and the lowest Aid flow (current US$) of Uganda?
Your answer should be very brief. 2.30e+07. 